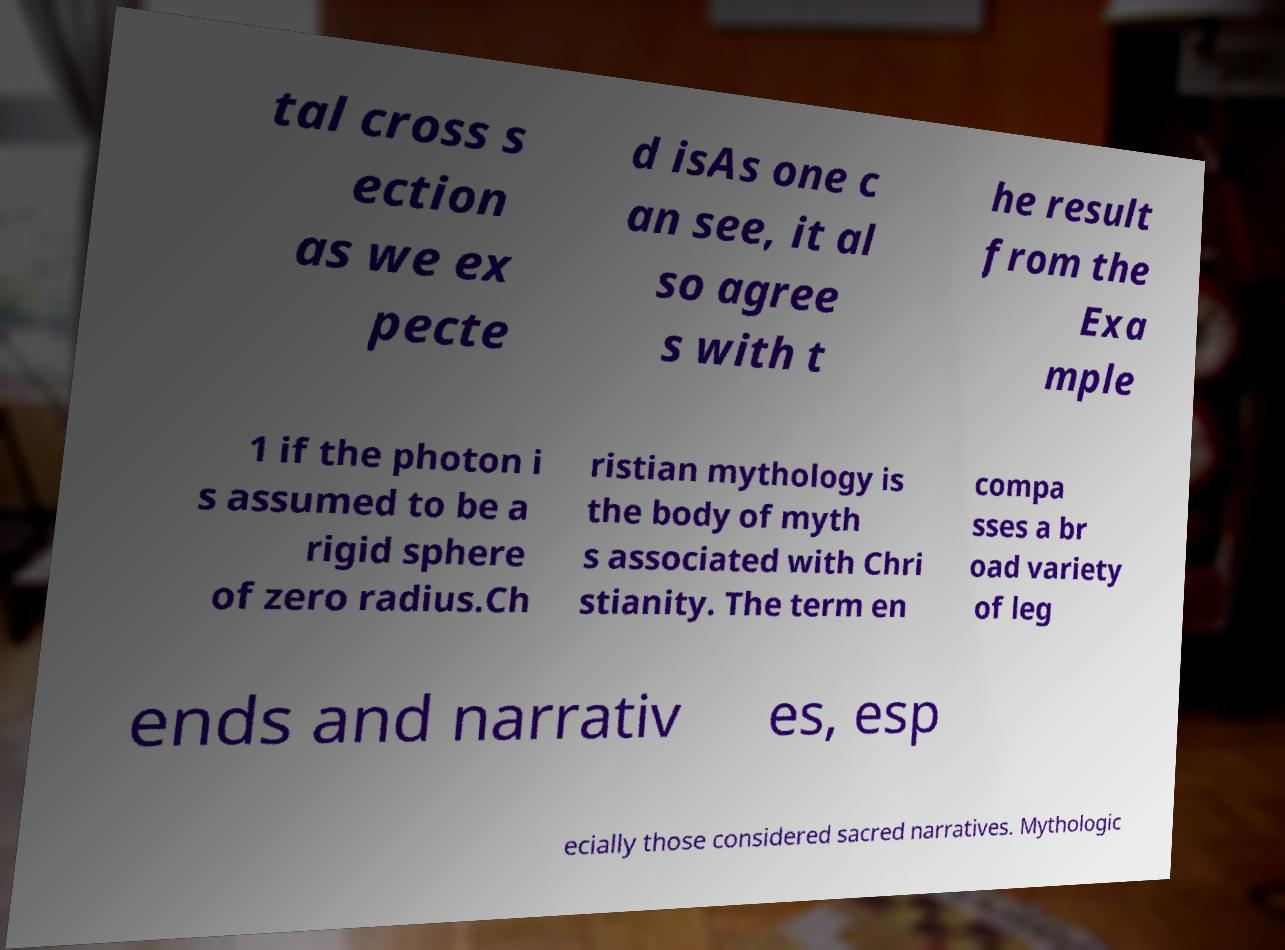Please read and relay the text visible in this image. What does it say? tal cross s ection as we ex pecte d isAs one c an see, it al so agree s with t he result from the Exa mple 1 if the photon i s assumed to be a rigid sphere of zero radius.Ch ristian mythology is the body of myth s associated with Chri stianity. The term en compa sses a br oad variety of leg ends and narrativ es, esp ecially those considered sacred narratives. Mythologic 